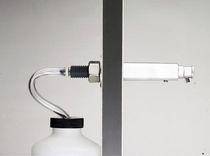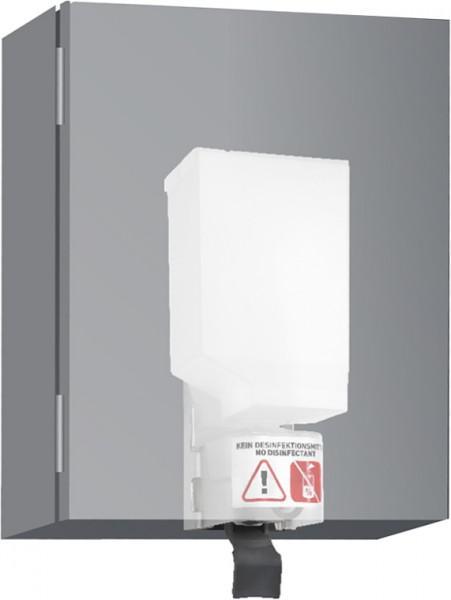The first image is the image on the left, the second image is the image on the right. Evaluate the accuracy of this statement regarding the images: "An image includes a single chrome spout that curves downward.". Is it true? Answer yes or no. No. The first image is the image on the left, the second image is the image on the right. For the images displayed, is the sentence "A built-in soap dispenser is next to a faucet in at least one of the images." factually correct? Answer yes or no. No. 